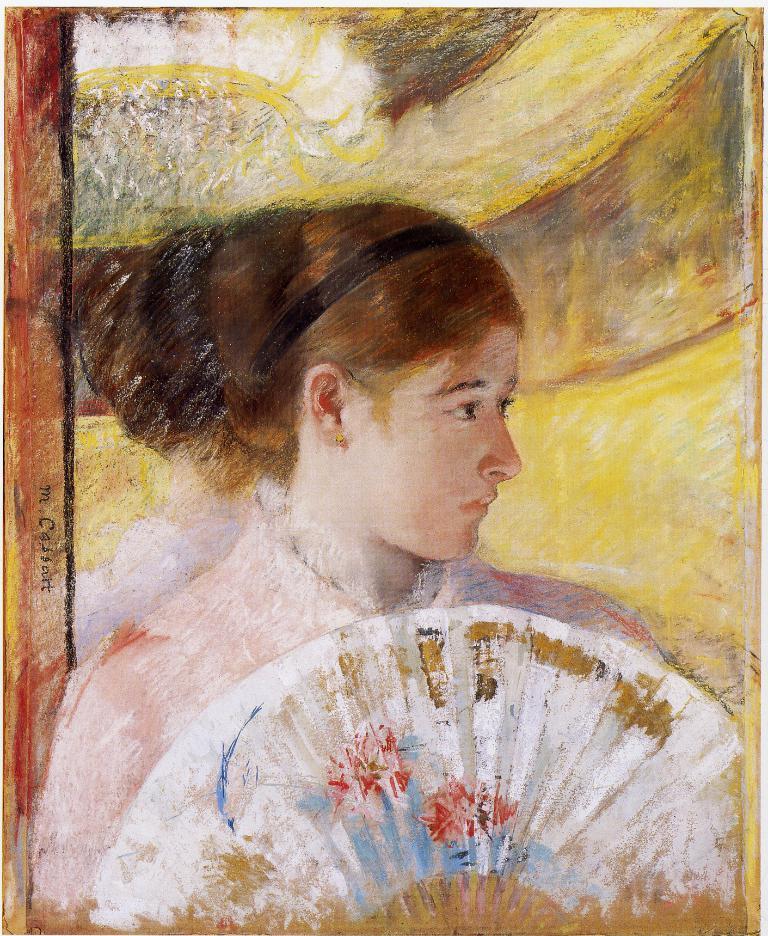In one or two sentences, can you explain what this image depicts? In this picture I can see the painting in front, where I can see a woman holding a Chinese fan. 